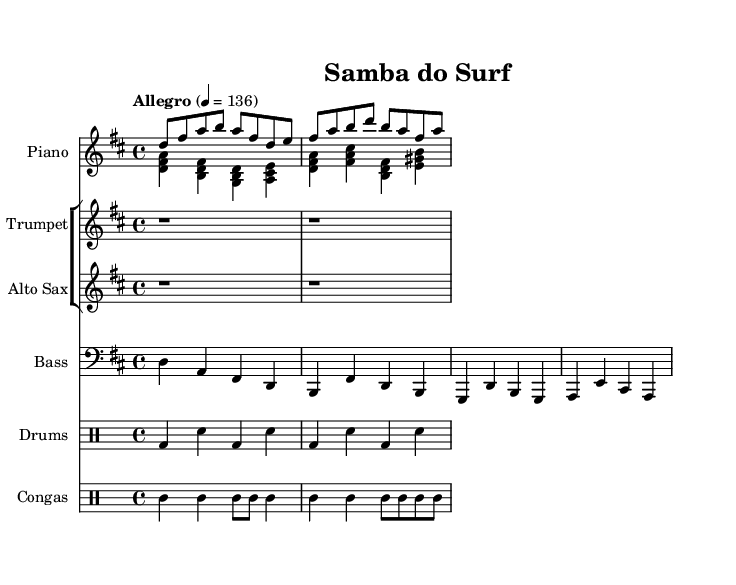What is the key signature of this music? The key signature is indicated at the beginning of the music sheet. It shows two sharps, which corresponds to D major.
Answer: D major What is the time signature of this music? The time signature is located at the beginning of the music, indicated by the fraction "4/4", which means four beats per measure.
Answer: 4/4 What tempo is indicated for this piece? The tempo is indicated in the music as "Allegro" with a metronome marking of 136 beats per minute, reflecting a fast pace.
Answer: Allegro, 136 How many instruments are used in this composition? By counting the staff groups and their respective instruments indicated in the music, there are five instruments: Piano, Trumpet, Alto Sax, Bass, and Drums with Congas.
Answer: Five What type of jazz influence is present in this piece? The piece has a Latin jazz influence, characterized by syncopated rhythms and a lively style suitable for dance, as evident in the upbeat tempo and instrumentation.
Answer: Latin jazz What is the specific clef used for the bass part? The bass part uses the bass clef, which is a standard clef for notating lower pitch ranges, and is indicated at the beginning of the bass staff.
Answer: Bass clef How is the rhythm characterized in this piece? The rhythm combines straight eighth notes and syncopated patterns, typical of samba music, creating a lively and upbeat feel that promotes a danceable quality.
Answer: Upbeat samba rhythm 